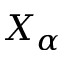Convert formula to latex. <formula><loc_0><loc_0><loc_500><loc_500>X _ { \alpha }</formula> 